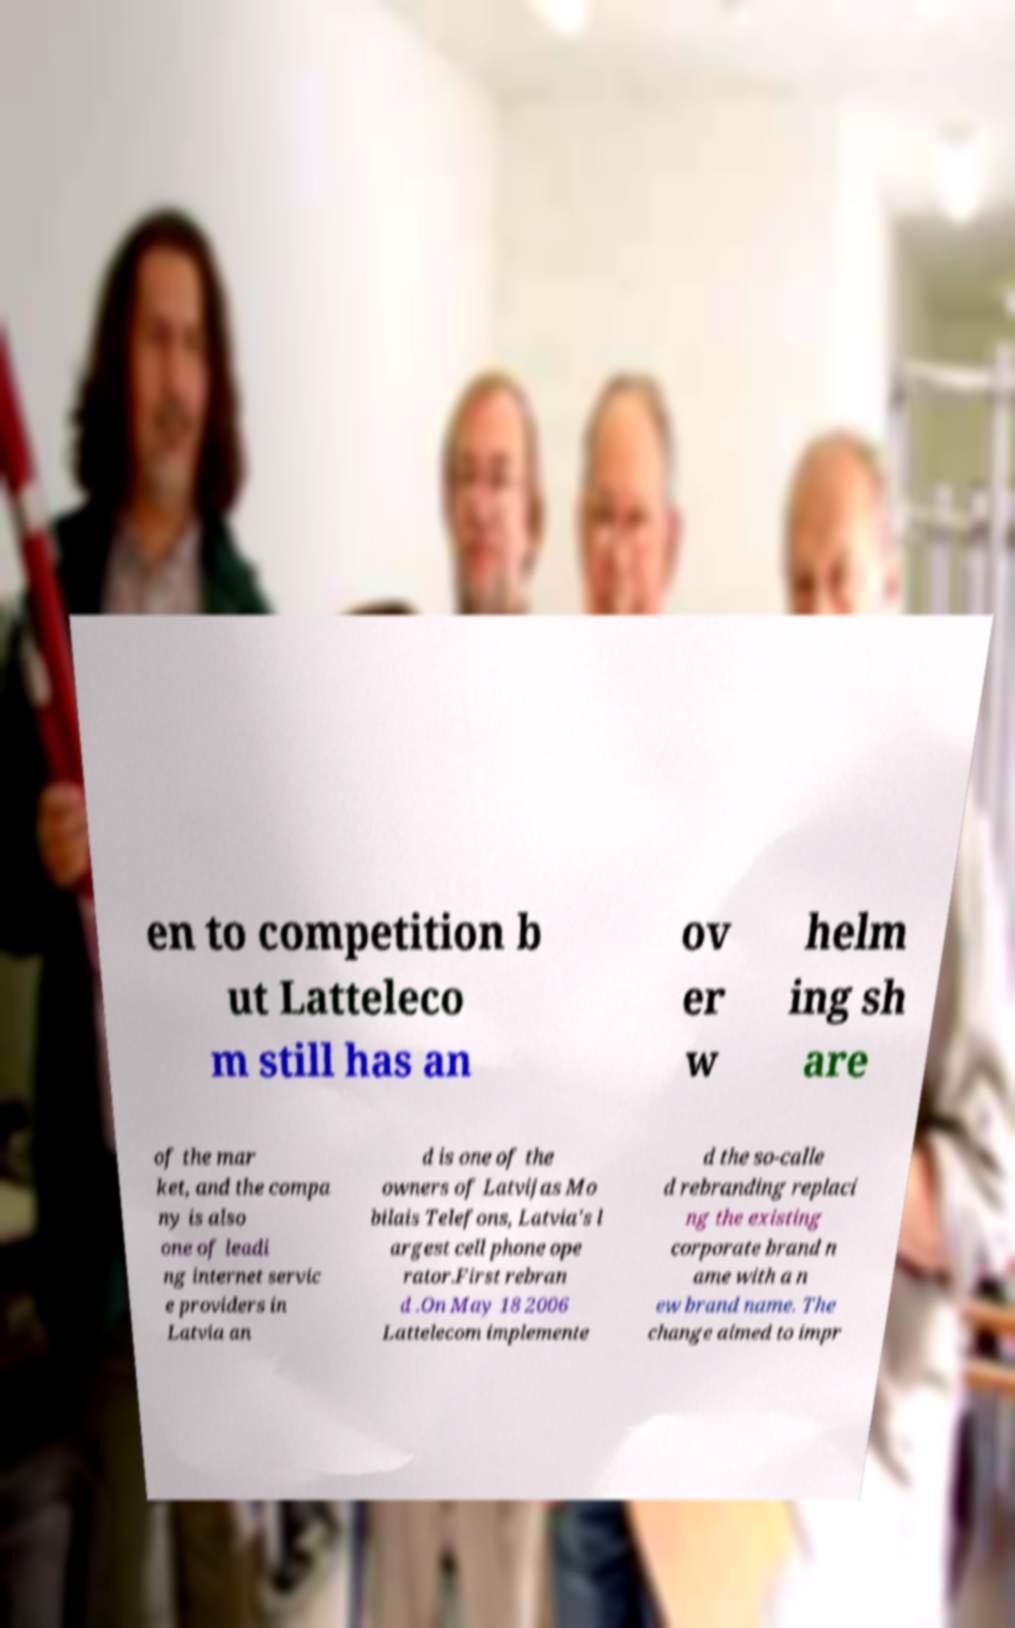Can you accurately transcribe the text from the provided image for me? en to competition b ut Latteleco m still has an ov er w helm ing sh are of the mar ket, and the compa ny is also one of leadi ng internet servic e providers in Latvia an d is one of the owners of Latvijas Mo bilais Telefons, Latvia's l argest cell phone ope rator.First rebran d .On May 18 2006 Lattelecom implemente d the so-calle d rebranding replaci ng the existing corporate brand n ame with a n ew brand name. The change aimed to impr 